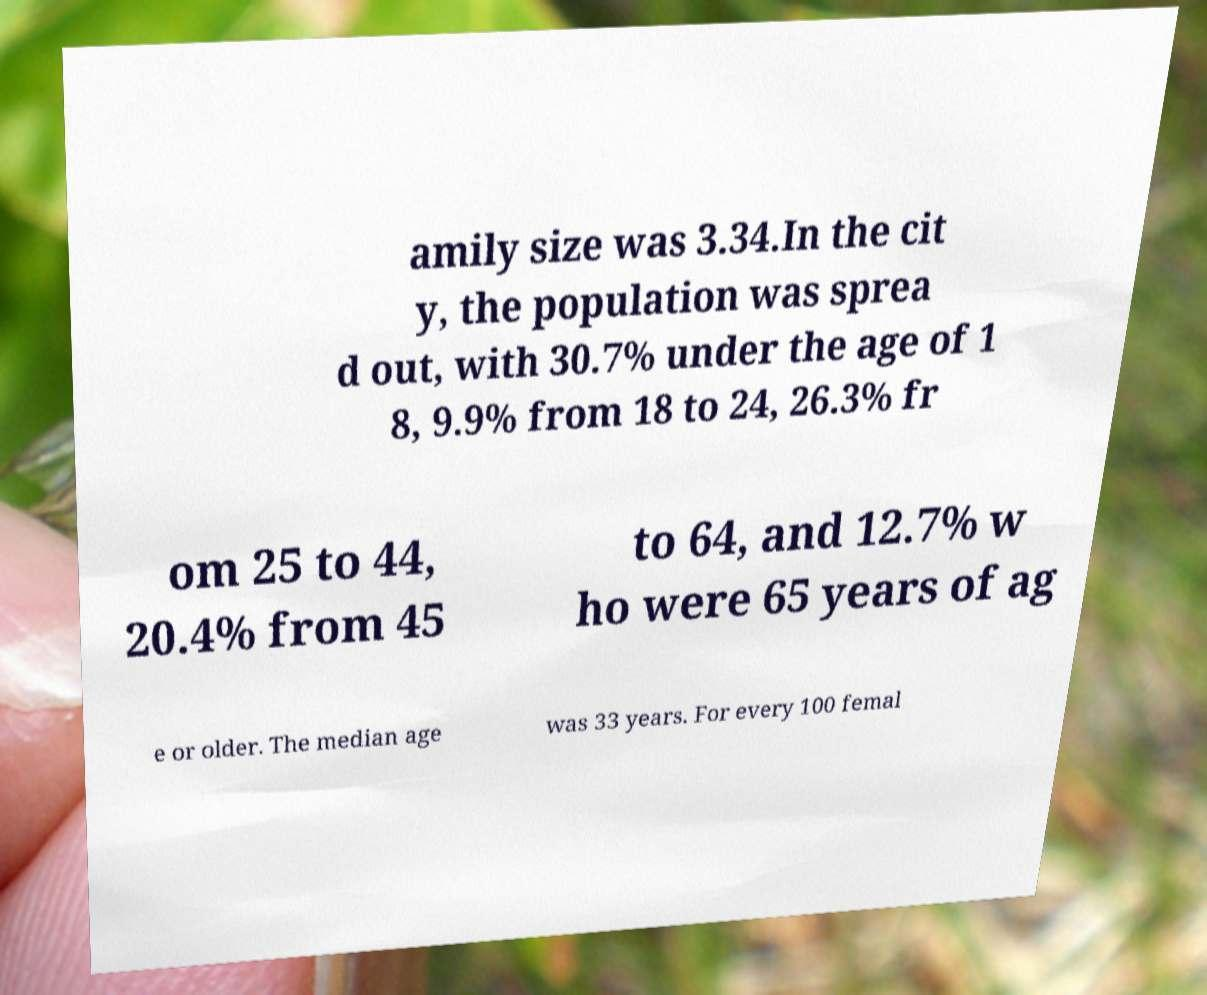Could you extract and type out the text from this image? amily size was 3.34.In the cit y, the population was sprea d out, with 30.7% under the age of 1 8, 9.9% from 18 to 24, 26.3% fr om 25 to 44, 20.4% from 45 to 64, and 12.7% w ho were 65 years of ag e or older. The median age was 33 years. For every 100 femal 